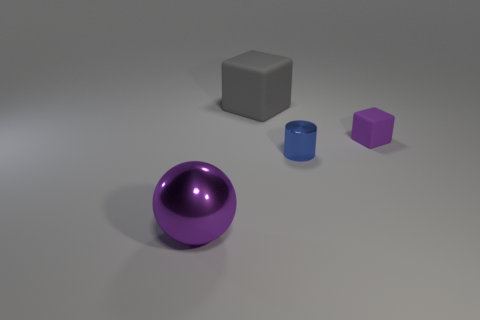Add 1 cyan matte balls. How many objects exist? 5 Subtract all cylinders. How many objects are left? 3 Subtract 0 red cylinders. How many objects are left? 4 Subtract all small gray shiny things. Subtract all tiny purple matte things. How many objects are left? 3 Add 2 large metal objects. How many large metal objects are left? 3 Add 2 matte cylinders. How many matte cylinders exist? 2 